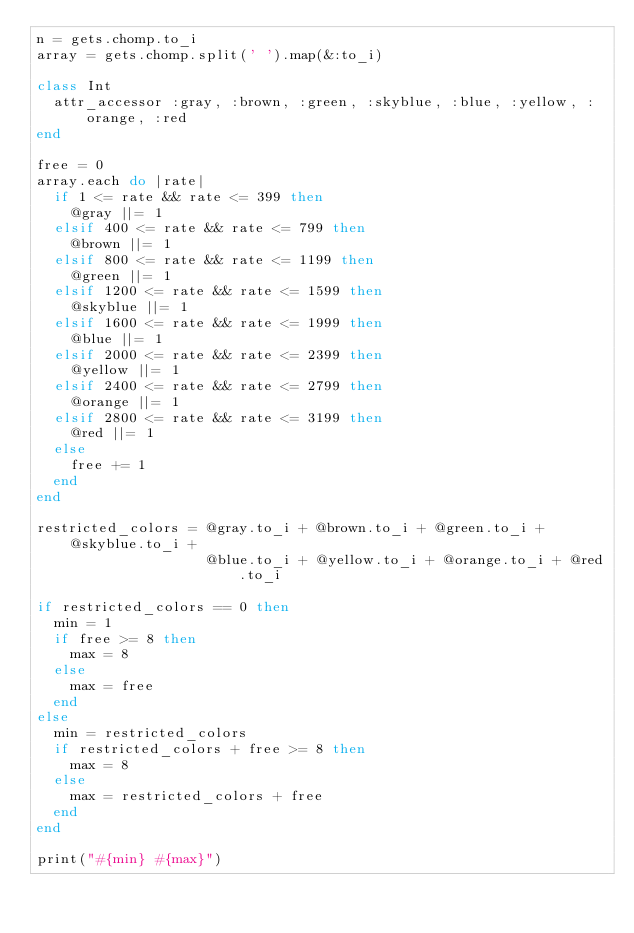Convert code to text. <code><loc_0><loc_0><loc_500><loc_500><_Ruby_>n = gets.chomp.to_i
array = gets.chomp.split(' ').map(&:to_i)

class Int
  attr_accessor :gray, :brown, :green, :skyblue, :blue, :yellow, :orange, :red
end

free = 0
array.each do |rate|
  if 1 <= rate && rate <= 399 then
    @gray ||= 1
  elsif 400 <= rate && rate <= 799 then
    @brown ||= 1
  elsif 800 <= rate && rate <= 1199 then
    @green ||= 1
  elsif 1200 <= rate && rate <= 1599 then
    @skyblue ||= 1
  elsif 1600 <= rate && rate <= 1999 then
    @blue ||= 1
  elsif 2000 <= rate && rate <= 2399 then
    @yellow ||= 1
  elsif 2400 <= rate && rate <= 2799 then
    @orange ||= 1
  elsif 2800 <= rate && rate <= 3199 then
    @red ||= 1
  else
    free += 1
  end
end

restricted_colors = @gray.to_i + @brown.to_i + @green.to_i + @skyblue.to_i +
                    @blue.to_i + @yellow.to_i + @orange.to_i + @red.to_i

if restricted_colors == 0 then
  min = 1
  if free >= 8 then
    max = 8
  else
    max = free
  end
else
  min = restricted_colors
  if restricted_colors + free >= 8 then
    max = 8
  else
    max = restricted_colors + free
  end
end

print("#{min} #{max}")</code> 